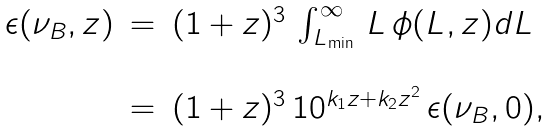Convert formula to latex. <formula><loc_0><loc_0><loc_500><loc_500>\begin{array} { l c l } \epsilon ( \nu _ { B } , z ) & = & ( 1 + z ) ^ { 3 } \, \int _ { L _ { \min } } ^ { \infty } \, L \, \phi ( L , z ) d L \\ \\ & = & ( 1 + z ) ^ { 3 } \, 1 0 ^ { k _ { 1 } z + k _ { 2 } z ^ { 2 } } \, \epsilon ( \nu _ { B } , 0 ) , \end{array}</formula> 